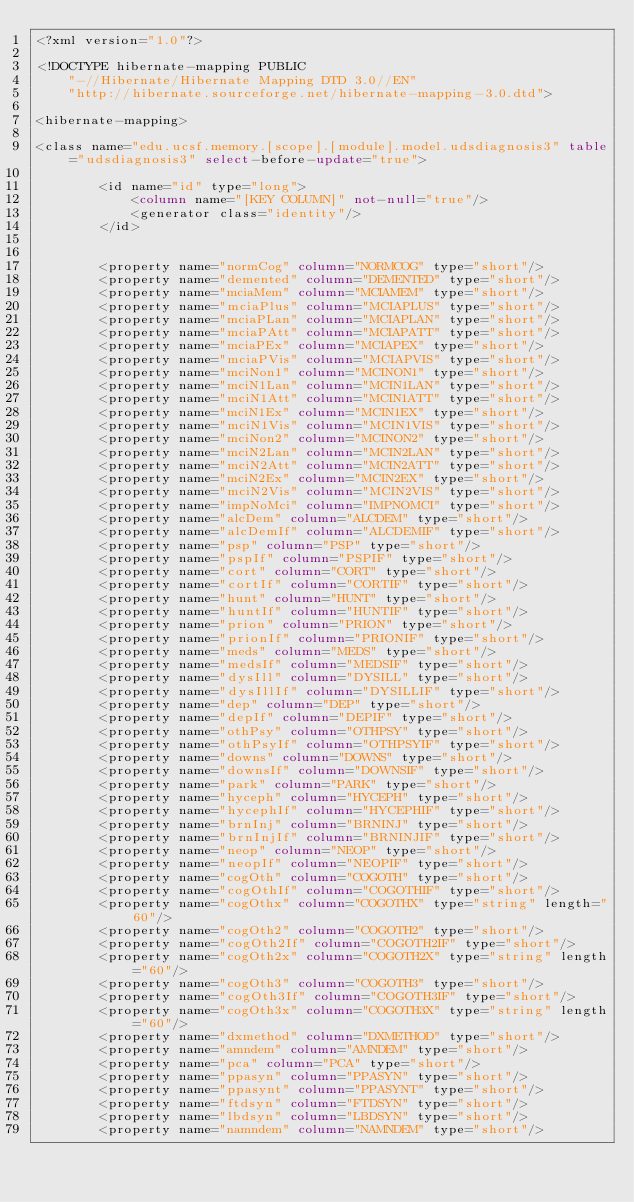<code> <loc_0><loc_0><loc_500><loc_500><_SQL_><?xml version="1.0"?>

<!DOCTYPE hibernate-mapping PUBLIC
    "-//Hibernate/Hibernate Mapping DTD 3.0//EN"
    "http://hibernate.sourceforge.net/hibernate-mapping-3.0.dtd">

<hibernate-mapping>

<class name="edu.ucsf.memory.[scope].[module].model.udsdiagnosis3" table="udsdiagnosis3" select-before-update="true">

		<id name="id" type="long">
			<column name="[KEY COLUMN]" not-null="true"/>
			<generator class="identity"/>
		</id>


		<property name="normCog" column="NORMCOG" type="short"/>
		<property name="demented" column="DEMENTED" type="short"/>
		<property name="mciaMem" column="MCIAMEM" type="short"/>
		<property name="mciaPlus" column="MCIAPLUS" type="short"/>
		<property name="mciaPLan" column="MCIAPLAN" type="short"/>
		<property name="mciaPAtt" column="MCIAPATT" type="short"/>
		<property name="mciaPEx" column="MCIAPEX" type="short"/>
		<property name="mciaPVis" column="MCIAPVIS" type="short"/>
		<property name="mciNon1" column="MCINON1" type="short"/>
		<property name="mciN1Lan" column="MCIN1LAN" type="short"/>
		<property name="mciN1Att" column="MCIN1ATT" type="short"/>
		<property name="mciN1Ex" column="MCIN1EX" type="short"/>
		<property name="mciN1Vis" column="MCIN1VIS" type="short"/>
		<property name="mciNon2" column="MCINON2" type="short"/>
		<property name="mciN2Lan" column="MCIN2LAN" type="short"/>
		<property name="mciN2Att" column="MCIN2ATT" type="short"/>
		<property name="mciN2Ex" column="MCIN2EX" type="short"/>
		<property name="mciN2Vis" column="MCIN2VIS" type="short"/>
		<property name="impNoMci" column="IMPNOMCI" type="short"/>
		<property name="alcDem" column="ALCDEM" type="short"/>
		<property name="alcDemIf" column="ALCDEMIF" type="short"/>
		<property name="psp" column="PSP" type="short"/>
		<property name="pspIf" column="PSPIF" type="short"/>
		<property name="cort" column="CORT" type="short"/>
		<property name="cortIf" column="CORTIF" type="short"/>
		<property name="hunt" column="HUNT" type="short"/>
		<property name="huntIf" column="HUNTIF" type="short"/>
		<property name="prion" column="PRION" type="short"/>
		<property name="prionIf" column="PRIONIF" type="short"/>
		<property name="meds" column="MEDS" type="short"/>
		<property name="medsIf" column="MEDSIF" type="short"/>
		<property name="dysIll" column="DYSILL" type="short"/>
		<property name="dysIllIf" column="DYSILLIF" type="short"/>
		<property name="dep" column="DEP" type="short"/>
		<property name="depIf" column="DEPIF" type="short"/>
		<property name="othPsy" column="OTHPSY" type="short"/>
		<property name="othPsyIf" column="OTHPSYIF" type="short"/>
		<property name="downs" column="DOWNS" type="short"/>
		<property name="downsIf" column="DOWNSIF" type="short"/>
		<property name="park" column="PARK" type="short"/>
		<property name="hyceph" column="HYCEPH" type="short"/>
		<property name="hycephIf" column="HYCEPHIF" type="short"/>
		<property name="brnInj" column="BRNINJ" type="short"/>
		<property name="brnInjIf" column="BRNINJIF" type="short"/>
		<property name="neop" column="NEOP" type="short"/>
		<property name="neopIf" column="NEOPIF" type="short"/>
		<property name="cogOth" column="COGOTH" type="short"/>
		<property name="cogOthIf" column="COGOTHIF" type="short"/>
		<property name="cogOthx" column="COGOTHX" type="string" length="60"/>
		<property name="cogOth2" column="COGOTH2" type="short"/>
		<property name="cogOth2If" column="COGOTH2IF" type="short"/>
		<property name="cogOth2x" column="COGOTH2X" type="string" length="60"/>
		<property name="cogOth3" column="COGOTH3" type="short"/>
		<property name="cogOth3If" column="COGOTH3IF" type="short"/>
		<property name="cogOth3x" column="COGOTH3X" type="string" length="60"/>
		<property name="dxmethod" column="DXMETHOD" type="short"/>
		<property name="amndem" column="AMNDEM" type="short"/>
		<property name="pca" column="PCA" type="short"/>
		<property name="ppasyn" column="PPASYN" type="short"/>
		<property name="ppasynt" column="PPASYNT" type="short"/>
		<property name="ftdsyn" column="FTDSYN" type="short"/>
		<property name="lbdsyn" column="LBDSYN" type="short"/>
		<property name="namndem" column="NAMNDEM" type="short"/></code> 